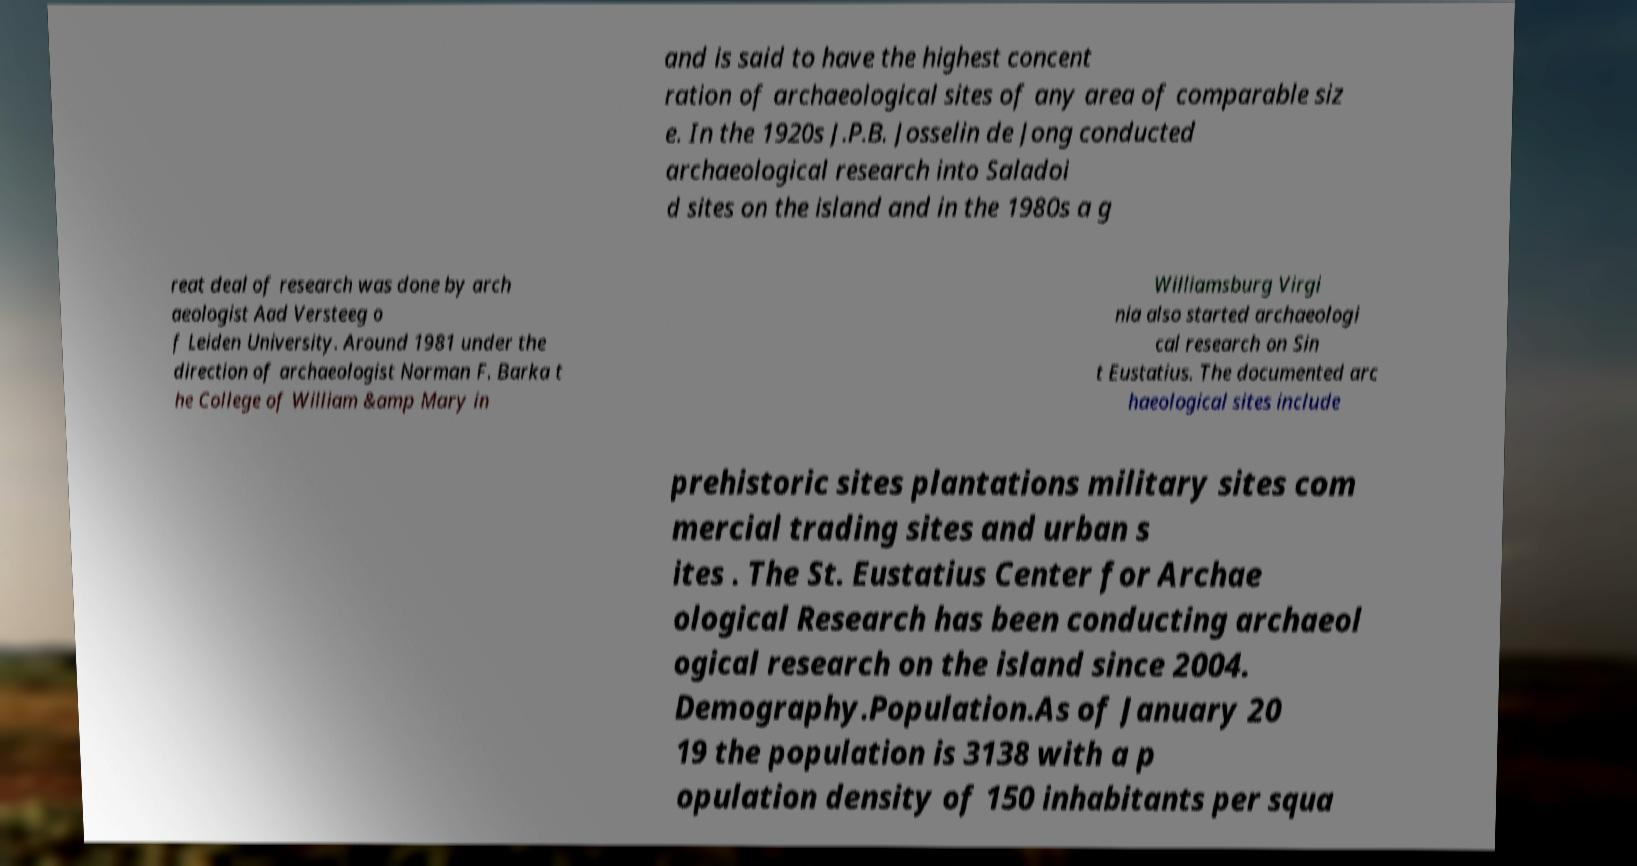For documentation purposes, I need the text within this image transcribed. Could you provide that? and is said to have the highest concent ration of archaeological sites of any area of comparable siz e. In the 1920s J.P.B. Josselin de Jong conducted archaeological research into Saladoi d sites on the island and in the 1980s a g reat deal of research was done by arch aeologist Aad Versteeg o f Leiden University. Around 1981 under the direction of archaeologist Norman F. Barka t he College of William &amp Mary in Williamsburg Virgi nia also started archaeologi cal research on Sin t Eustatius. The documented arc haeological sites include prehistoric sites plantations military sites com mercial trading sites and urban s ites . The St. Eustatius Center for Archae ological Research has been conducting archaeol ogical research on the island since 2004. Demography.Population.As of January 20 19 the population is 3138 with a p opulation density of 150 inhabitants per squa 